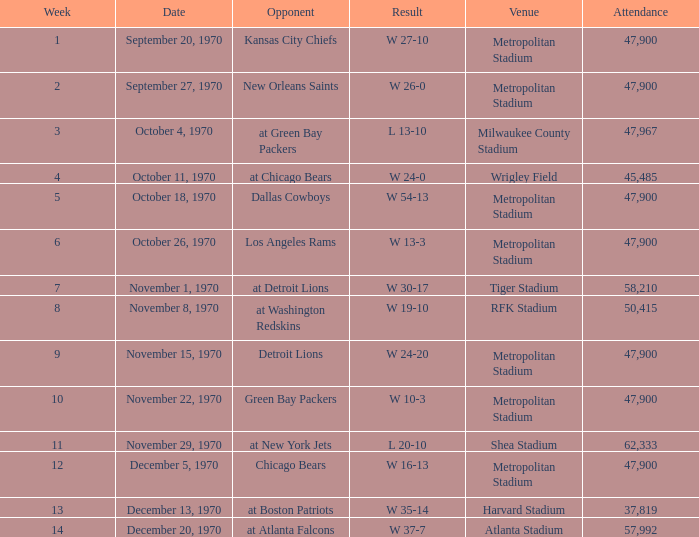How many people attended the game with a result of w 16-13 and a week earlier than 12? None. 